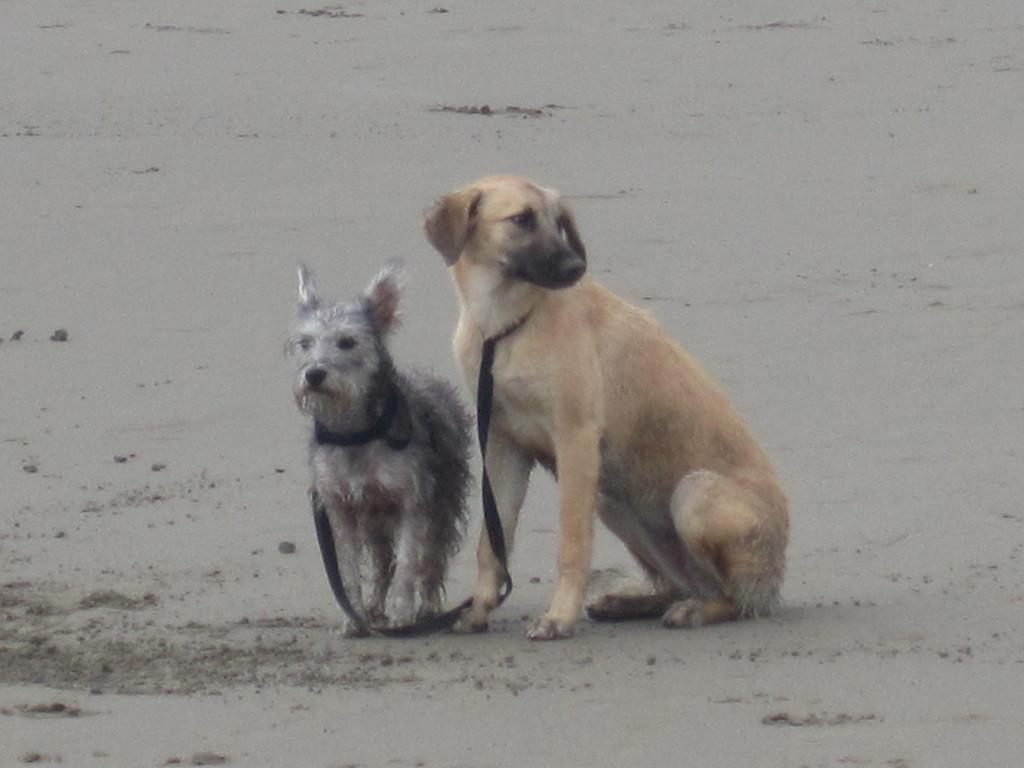How many dogs are present in the image? There are two dogs in the image. What are the dogs wearing in the image? The dogs are wearing black belts. What type of surface is visible in the background of the image? There is sand visible in the background of the image. What type of slope can be seen in the image? There is no slope present in the image. What team do the dogs belong to in the image? The dogs are not part of a team in the image. What type of tools might a carpenter use in the image? There are no tools or carpenters present in the image. 